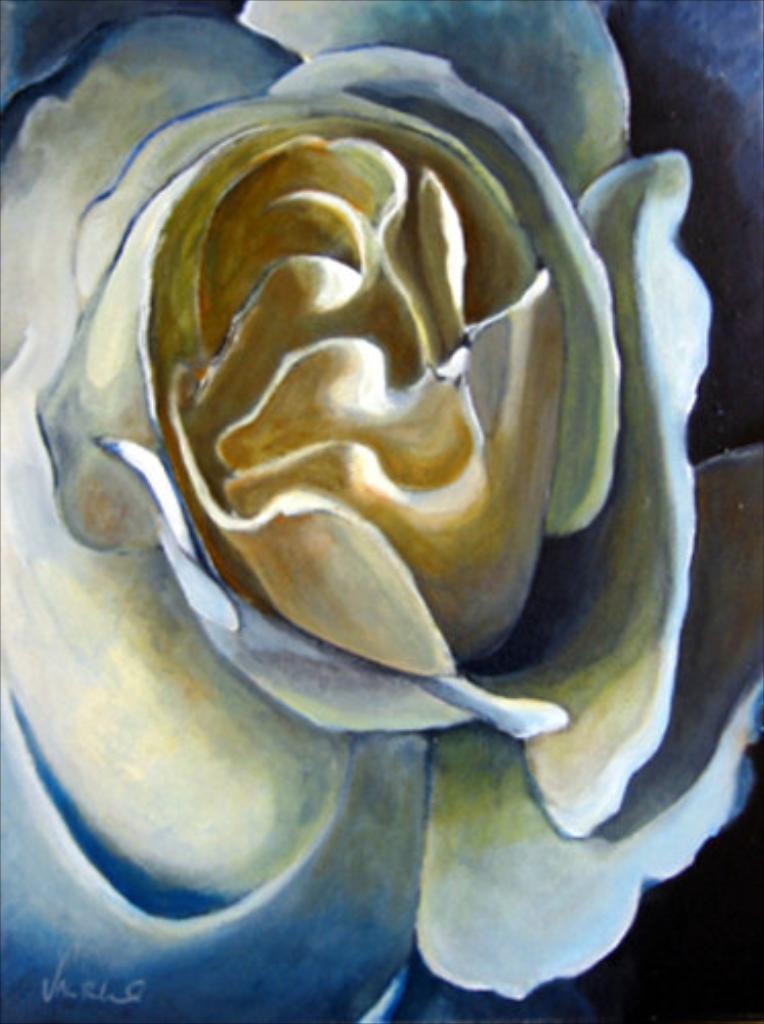Can you describe this image briefly? In the center of the image, we can see a painting of a flower and at the bottom, there is some text. 